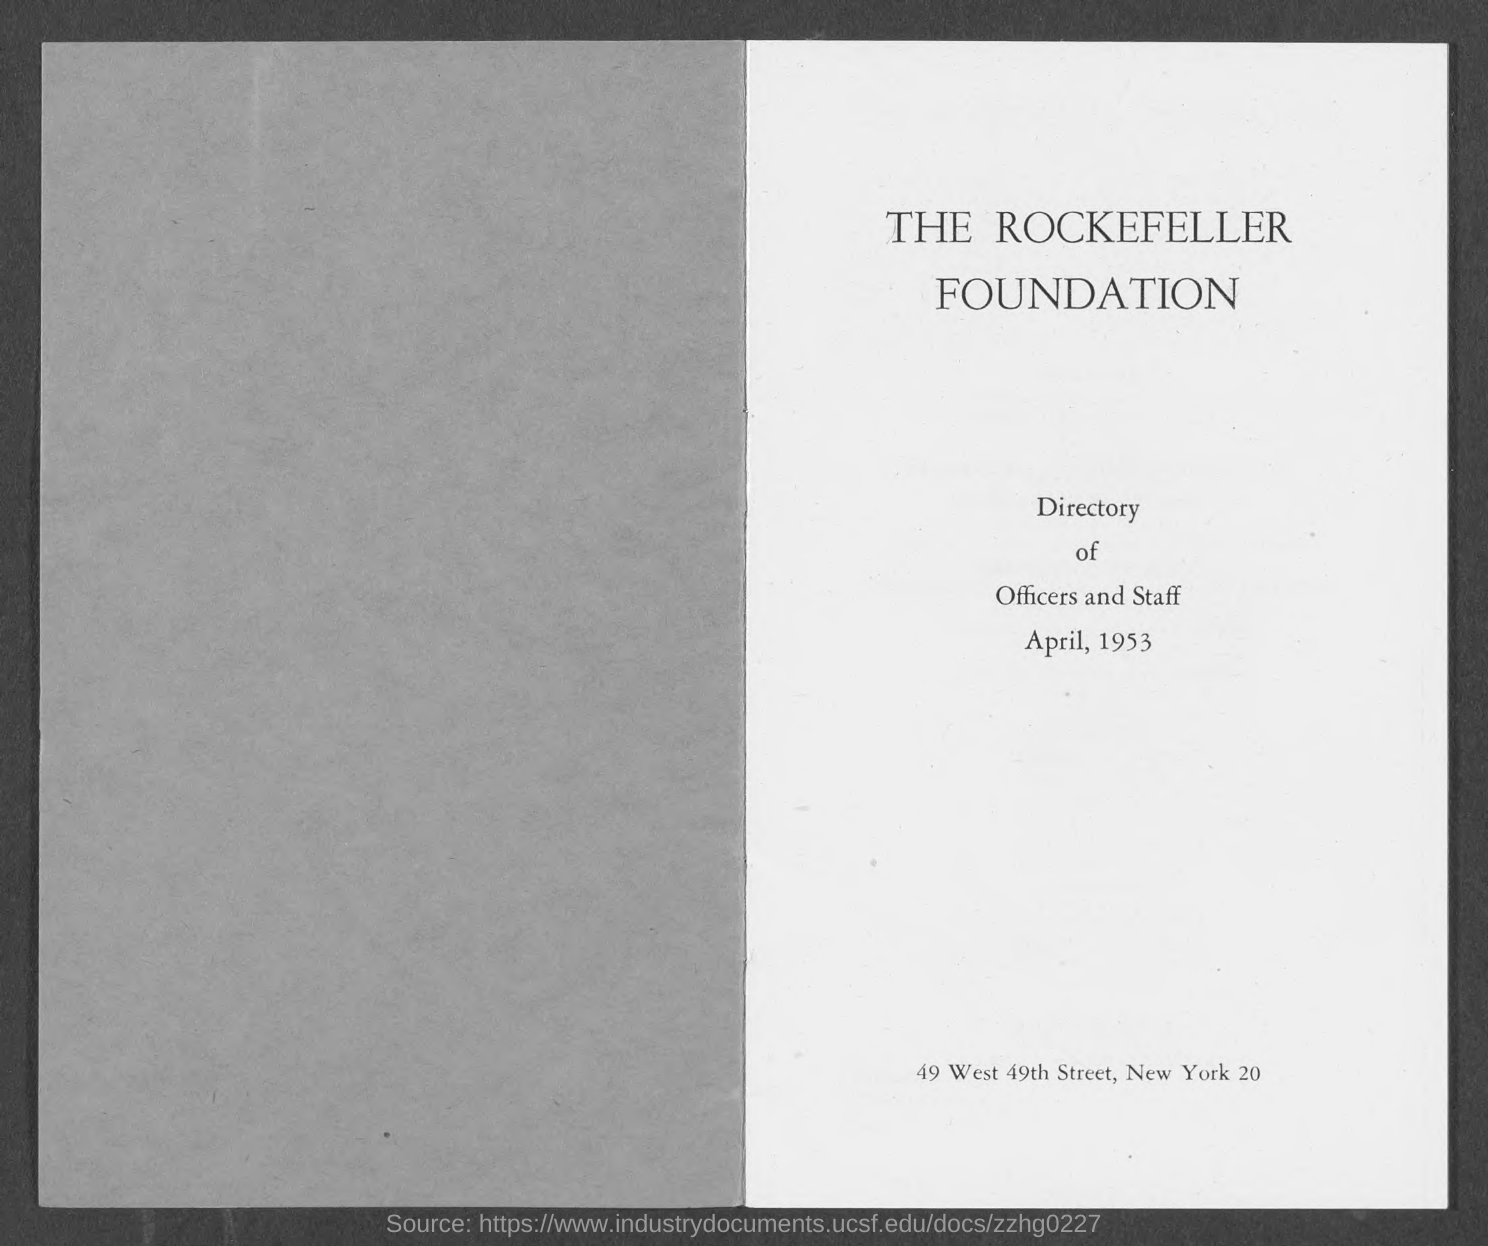What is the name of the foundation?
Give a very brief answer. THE ROCKEFELLER FOUNDATION. 